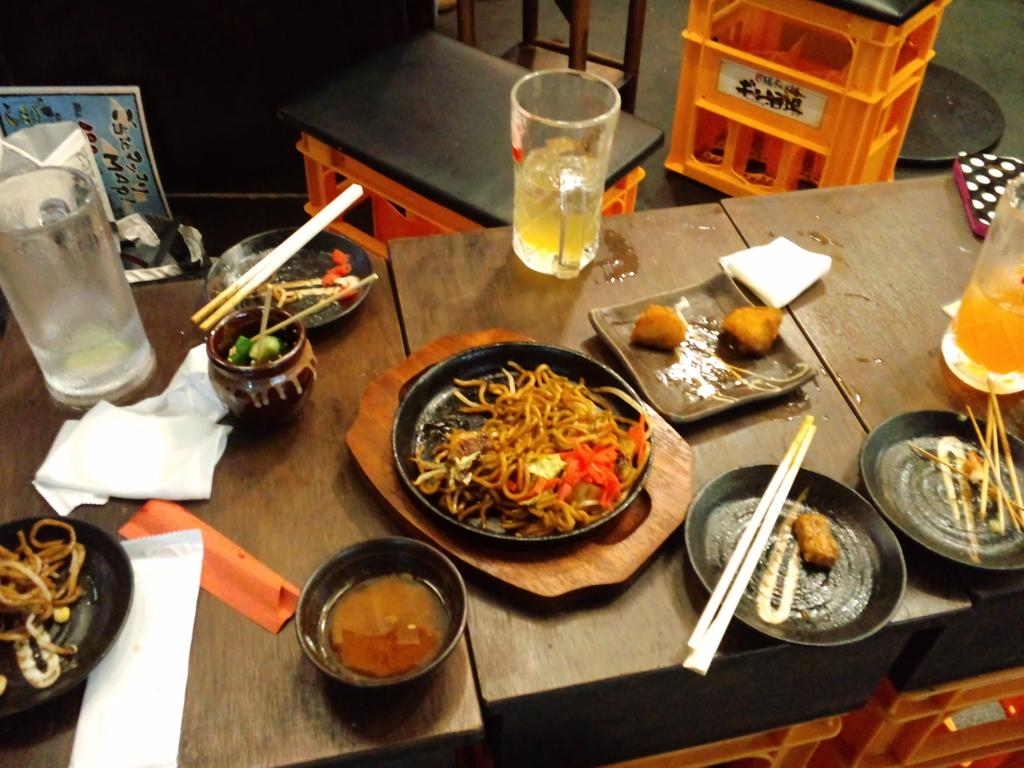What type of furniture is present in the image? There is a table and a stool in the image. What items are on the table in the image? There is a bowl, a plate, a jar, chopsticks, a pot, a glass, and tissue paper on the table. What can be found inside the bowl, plate, or pot? There is food in the bowl, plate, or pot. Is there any decorative element in the image? Yes, there is a poster in the image. What type of quiver is visible in the image? There is no quiver present in the image. What type of bait is used for the fish in the image? There are no fish or bait present in the image. 